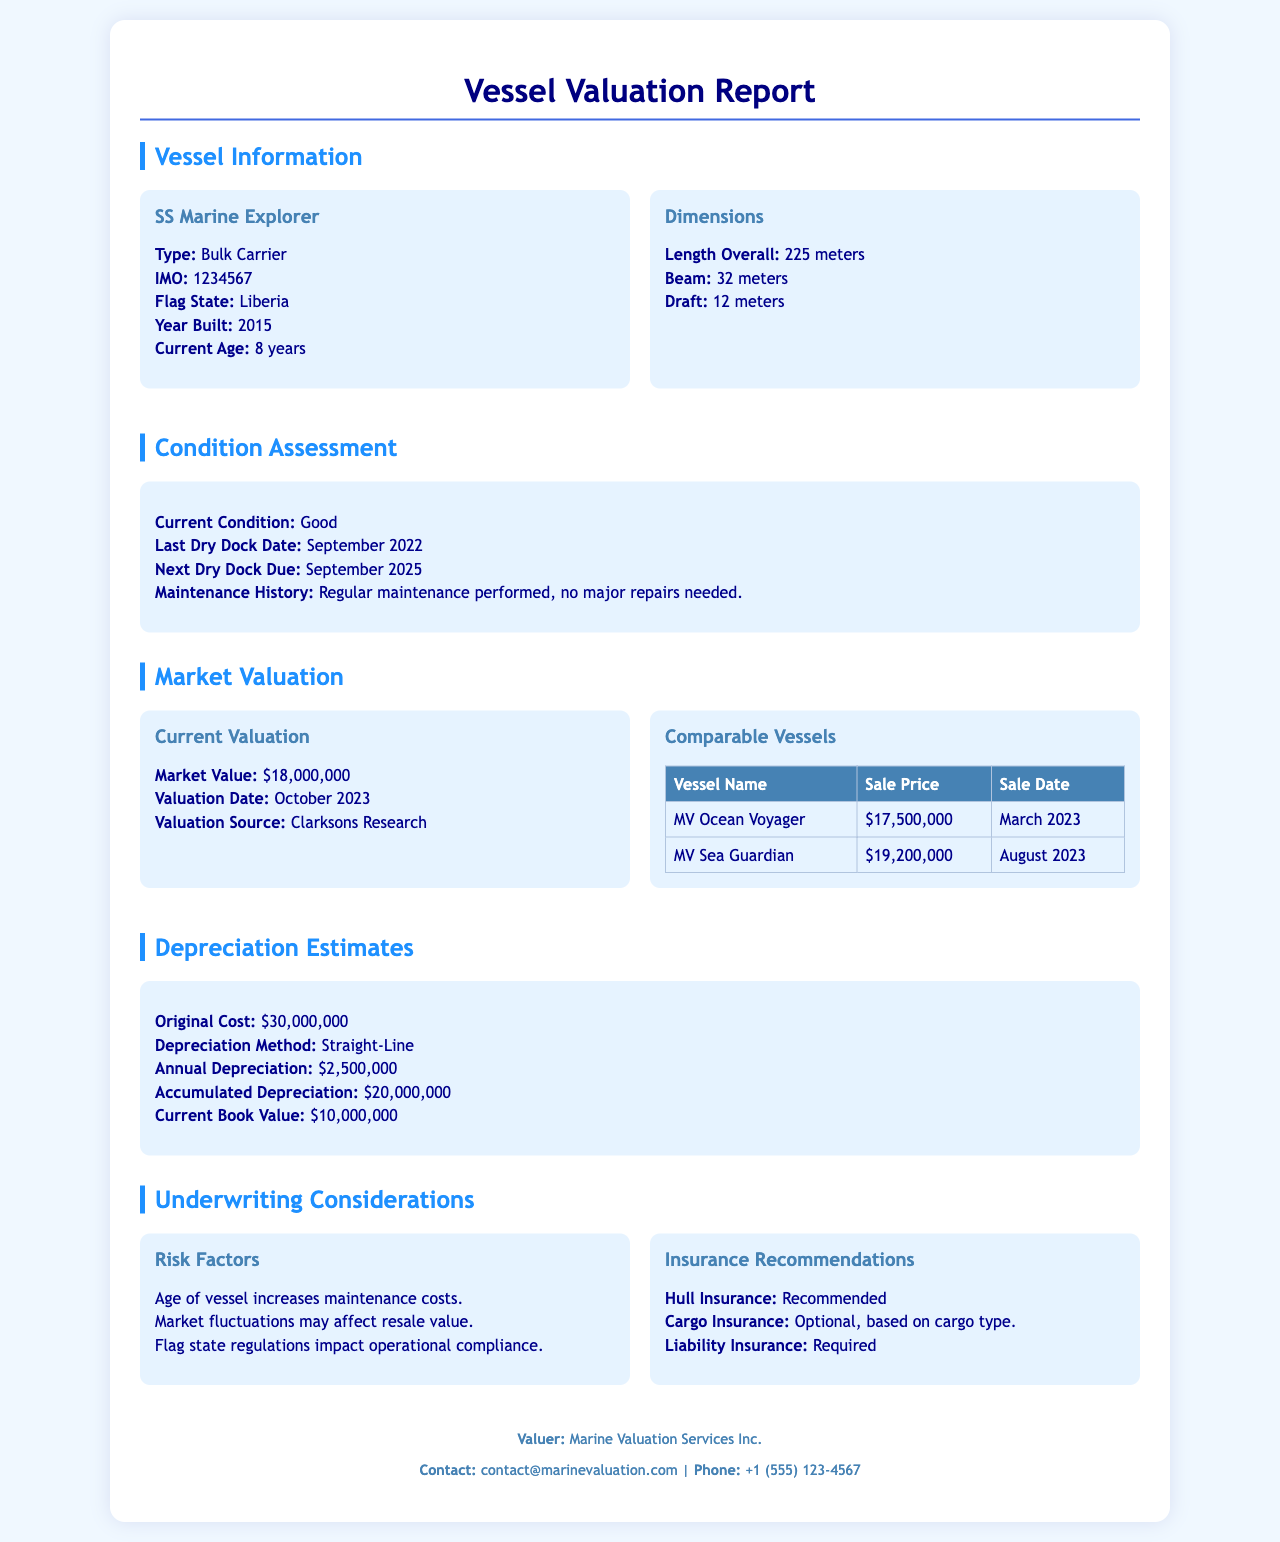What is the type of the vessel? The type of the vessel is listed under the Vessel Information section.
Answer: Bulk Carrier What is the market value of the SS Marine Explorer? The market value is found in the Market Valuation section.
Answer: $18,000,000 When was the last dry dock date? The last dry dock date is noted in the Condition Assessment section.
Answer: September 2022 What is the age of the vessel? The current age is mentioned in the Vessel Information section.
Answer: 8 years What is the annual depreciation for the SS Marine Explorer? The annual depreciation is specified under Depreciation Estimates.
Answer: $2,500,000 What is the flag state of the vessel? The flag state is mentioned in the Vessel Information section.
Answer: Liberia What is the accumulated depreciation? The accumulated depreciation is found in the Depreciation Estimates section.
Answer: $20,000,000 What are the insurance recommendations for the cargo? Insurance recommendations can be found in the Underwriting Considerations section.
Answer: Optional, based on cargo type What is the original cost of the vessel? The original cost is stated in the Depreciation Estimates section.
Answer: $30,000,000 